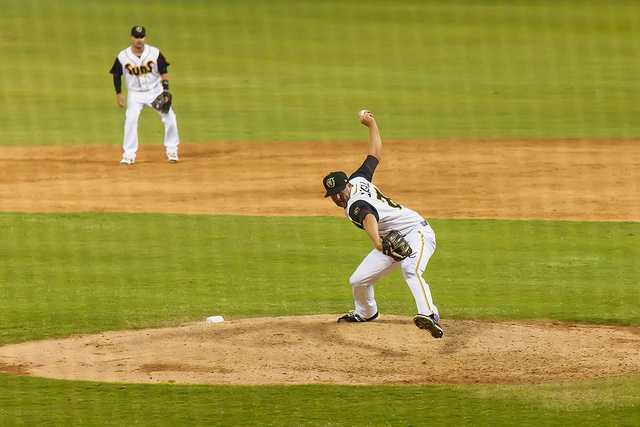Describe the objects in this image and their specific colors. I can see people in olive, lightgray, black, and tan tones, people in olive, lightgray, and black tones, baseball glove in olive, black, and gray tones, baseball glove in olive, black, and gray tones, and sports ball in olive, ivory, and tan tones in this image. 